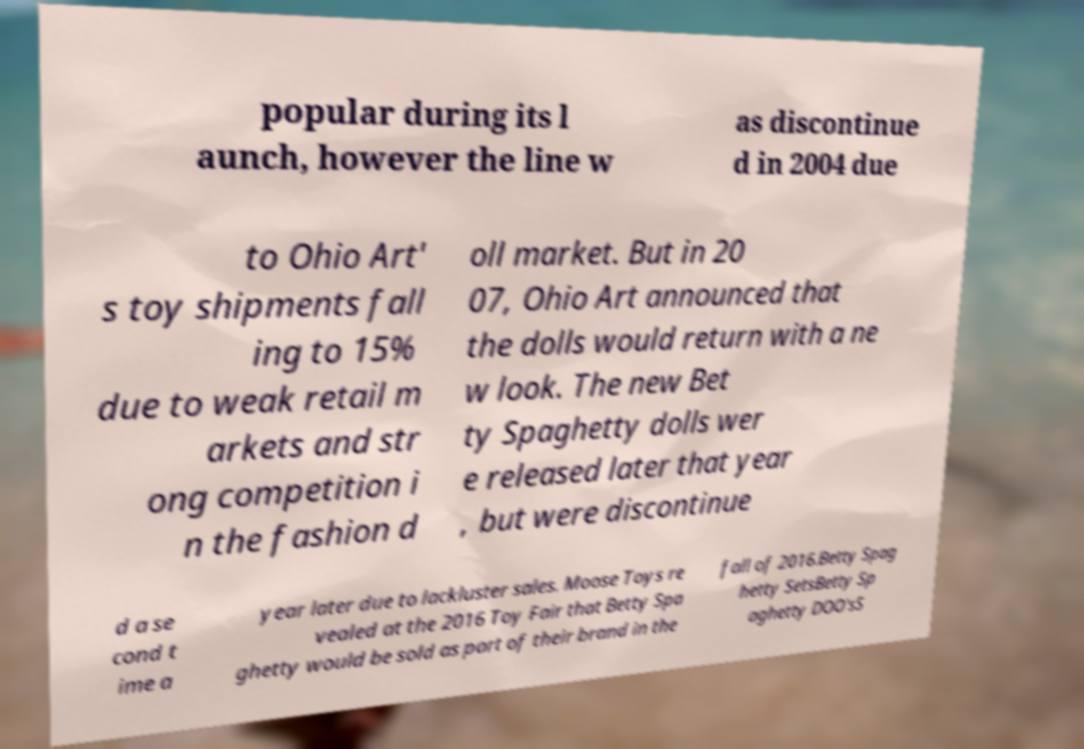For documentation purposes, I need the text within this image transcribed. Could you provide that? popular during its l aunch, however the line w as discontinue d in 2004 due to Ohio Art' s toy shipments fall ing to 15% due to weak retail m arkets and str ong competition i n the fashion d oll market. But in 20 07, Ohio Art announced that the dolls would return with a ne w look. The new Bet ty Spaghetty dolls wer e released later that year , but were discontinue d a se cond t ime a year later due to lackluster sales. Moose Toys re vealed at the 2016 Toy Fair that Betty Spa ghetty would be sold as part of their brand in the fall of 2016.Betty Spag hetty SetsBetty Sp aghetty DOO'sS 